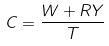<formula> <loc_0><loc_0><loc_500><loc_500>C = \frac { W + R Y } { T }</formula> 